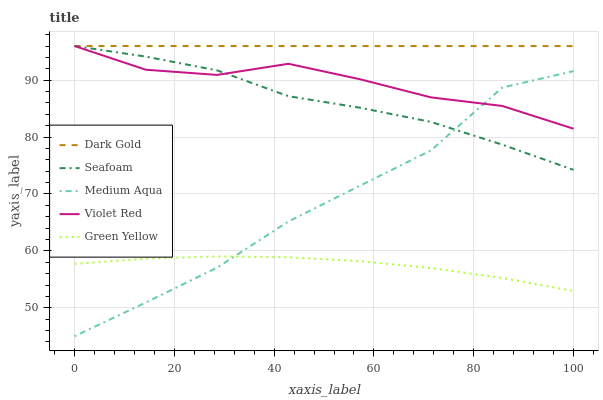Does Medium Aqua have the minimum area under the curve?
Answer yes or no. No. Does Medium Aqua have the maximum area under the curve?
Answer yes or no. No. Is Green Yellow the smoothest?
Answer yes or no. No. Is Green Yellow the roughest?
Answer yes or no. No. Does Green Yellow have the lowest value?
Answer yes or no. No. Does Medium Aqua have the highest value?
Answer yes or no. No. Is Green Yellow less than Dark Gold?
Answer yes or no. Yes. Is Seafoam greater than Green Yellow?
Answer yes or no. Yes. Does Green Yellow intersect Dark Gold?
Answer yes or no. No. 